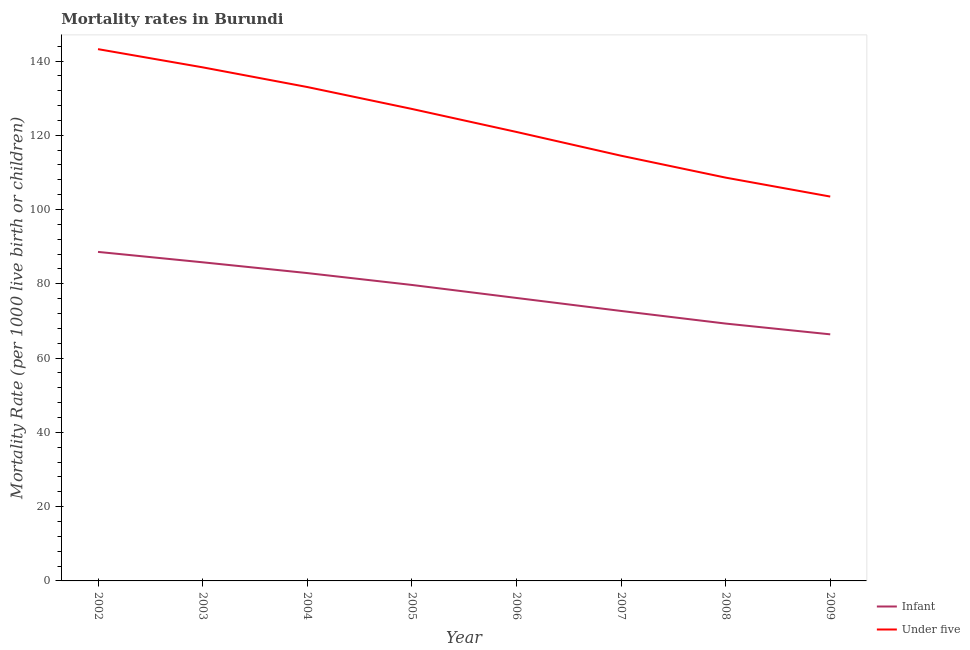What is the under-5 mortality rate in 2009?
Give a very brief answer. 103.5. Across all years, what is the maximum infant mortality rate?
Offer a very short reply. 88.6. Across all years, what is the minimum infant mortality rate?
Your answer should be very brief. 66.4. In which year was the under-5 mortality rate maximum?
Ensure brevity in your answer.  2002. What is the total under-5 mortality rate in the graph?
Your answer should be compact. 989.1. What is the difference between the under-5 mortality rate in 2006 and that in 2008?
Your answer should be very brief. 12.3. What is the difference between the infant mortality rate in 2003 and the under-5 mortality rate in 2007?
Keep it short and to the point. -28.7. What is the average infant mortality rate per year?
Give a very brief answer. 77.7. In the year 2007, what is the difference between the infant mortality rate and under-5 mortality rate?
Make the answer very short. -41.8. What is the ratio of the infant mortality rate in 2006 to that in 2008?
Keep it short and to the point. 1.1. Is the under-5 mortality rate in 2003 less than that in 2006?
Provide a succinct answer. No. What is the difference between the highest and the second highest under-5 mortality rate?
Your response must be concise. 4.9. What is the difference between the highest and the lowest under-5 mortality rate?
Make the answer very short. 39.7. Does the under-5 mortality rate monotonically increase over the years?
Offer a terse response. No. Is the infant mortality rate strictly greater than the under-5 mortality rate over the years?
Ensure brevity in your answer.  No. How many years are there in the graph?
Your answer should be compact. 8. Are the values on the major ticks of Y-axis written in scientific E-notation?
Offer a very short reply. No. How are the legend labels stacked?
Offer a terse response. Vertical. What is the title of the graph?
Your answer should be very brief. Mortality rates in Burundi. Does "Money lenders" appear as one of the legend labels in the graph?
Offer a very short reply. No. What is the label or title of the Y-axis?
Provide a short and direct response. Mortality Rate (per 1000 live birth or children). What is the Mortality Rate (per 1000 live birth or children) of Infant in 2002?
Your answer should be very brief. 88.6. What is the Mortality Rate (per 1000 live birth or children) of Under five in 2002?
Provide a succinct answer. 143.2. What is the Mortality Rate (per 1000 live birth or children) of Infant in 2003?
Your answer should be very brief. 85.8. What is the Mortality Rate (per 1000 live birth or children) in Under five in 2003?
Keep it short and to the point. 138.3. What is the Mortality Rate (per 1000 live birth or children) of Infant in 2004?
Give a very brief answer. 82.9. What is the Mortality Rate (per 1000 live birth or children) of Under five in 2004?
Your response must be concise. 133. What is the Mortality Rate (per 1000 live birth or children) of Infant in 2005?
Your answer should be compact. 79.7. What is the Mortality Rate (per 1000 live birth or children) of Under five in 2005?
Offer a very short reply. 127.1. What is the Mortality Rate (per 1000 live birth or children) of Infant in 2006?
Offer a very short reply. 76.2. What is the Mortality Rate (per 1000 live birth or children) in Under five in 2006?
Ensure brevity in your answer.  120.9. What is the Mortality Rate (per 1000 live birth or children) of Infant in 2007?
Your answer should be compact. 72.7. What is the Mortality Rate (per 1000 live birth or children) in Under five in 2007?
Give a very brief answer. 114.5. What is the Mortality Rate (per 1000 live birth or children) of Infant in 2008?
Provide a succinct answer. 69.3. What is the Mortality Rate (per 1000 live birth or children) of Under five in 2008?
Keep it short and to the point. 108.6. What is the Mortality Rate (per 1000 live birth or children) of Infant in 2009?
Ensure brevity in your answer.  66.4. What is the Mortality Rate (per 1000 live birth or children) of Under five in 2009?
Provide a short and direct response. 103.5. Across all years, what is the maximum Mortality Rate (per 1000 live birth or children) of Infant?
Offer a very short reply. 88.6. Across all years, what is the maximum Mortality Rate (per 1000 live birth or children) in Under five?
Provide a short and direct response. 143.2. Across all years, what is the minimum Mortality Rate (per 1000 live birth or children) in Infant?
Offer a very short reply. 66.4. Across all years, what is the minimum Mortality Rate (per 1000 live birth or children) in Under five?
Your response must be concise. 103.5. What is the total Mortality Rate (per 1000 live birth or children) of Infant in the graph?
Offer a very short reply. 621.6. What is the total Mortality Rate (per 1000 live birth or children) in Under five in the graph?
Make the answer very short. 989.1. What is the difference between the Mortality Rate (per 1000 live birth or children) in Infant in 2002 and that in 2003?
Provide a succinct answer. 2.8. What is the difference between the Mortality Rate (per 1000 live birth or children) in Under five in 2002 and that in 2003?
Offer a terse response. 4.9. What is the difference between the Mortality Rate (per 1000 live birth or children) in Infant in 2002 and that in 2006?
Give a very brief answer. 12.4. What is the difference between the Mortality Rate (per 1000 live birth or children) of Under five in 2002 and that in 2006?
Ensure brevity in your answer.  22.3. What is the difference between the Mortality Rate (per 1000 live birth or children) of Under five in 2002 and that in 2007?
Your response must be concise. 28.7. What is the difference between the Mortality Rate (per 1000 live birth or children) of Infant in 2002 and that in 2008?
Provide a succinct answer. 19.3. What is the difference between the Mortality Rate (per 1000 live birth or children) of Under five in 2002 and that in 2008?
Offer a terse response. 34.6. What is the difference between the Mortality Rate (per 1000 live birth or children) in Under five in 2002 and that in 2009?
Offer a very short reply. 39.7. What is the difference between the Mortality Rate (per 1000 live birth or children) of Under five in 2003 and that in 2005?
Your response must be concise. 11.2. What is the difference between the Mortality Rate (per 1000 live birth or children) in Infant in 2003 and that in 2006?
Give a very brief answer. 9.6. What is the difference between the Mortality Rate (per 1000 live birth or children) of Under five in 2003 and that in 2006?
Your response must be concise. 17.4. What is the difference between the Mortality Rate (per 1000 live birth or children) of Under five in 2003 and that in 2007?
Make the answer very short. 23.8. What is the difference between the Mortality Rate (per 1000 live birth or children) of Under five in 2003 and that in 2008?
Ensure brevity in your answer.  29.7. What is the difference between the Mortality Rate (per 1000 live birth or children) in Under five in 2003 and that in 2009?
Give a very brief answer. 34.8. What is the difference between the Mortality Rate (per 1000 live birth or children) of Infant in 2004 and that in 2005?
Keep it short and to the point. 3.2. What is the difference between the Mortality Rate (per 1000 live birth or children) of Under five in 2004 and that in 2006?
Keep it short and to the point. 12.1. What is the difference between the Mortality Rate (per 1000 live birth or children) of Under five in 2004 and that in 2007?
Offer a very short reply. 18.5. What is the difference between the Mortality Rate (per 1000 live birth or children) in Infant in 2004 and that in 2008?
Your answer should be very brief. 13.6. What is the difference between the Mortality Rate (per 1000 live birth or children) of Under five in 2004 and that in 2008?
Provide a succinct answer. 24.4. What is the difference between the Mortality Rate (per 1000 live birth or children) in Infant in 2004 and that in 2009?
Your answer should be very brief. 16.5. What is the difference between the Mortality Rate (per 1000 live birth or children) in Under five in 2004 and that in 2009?
Keep it short and to the point. 29.5. What is the difference between the Mortality Rate (per 1000 live birth or children) of Infant in 2005 and that in 2006?
Offer a terse response. 3.5. What is the difference between the Mortality Rate (per 1000 live birth or children) of Under five in 2005 and that in 2007?
Give a very brief answer. 12.6. What is the difference between the Mortality Rate (per 1000 live birth or children) of Infant in 2005 and that in 2008?
Offer a very short reply. 10.4. What is the difference between the Mortality Rate (per 1000 live birth or children) in Under five in 2005 and that in 2008?
Your response must be concise. 18.5. What is the difference between the Mortality Rate (per 1000 live birth or children) in Infant in 2005 and that in 2009?
Provide a short and direct response. 13.3. What is the difference between the Mortality Rate (per 1000 live birth or children) of Under five in 2005 and that in 2009?
Your answer should be compact. 23.6. What is the difference between the Mortality Rate (per 1000 live birth or children) in Infant in 2006 and that in 2008?
Offer a terse response. 6.9. What is the difference between the Mortality Rate (per 1000 live birth or children) of Under five in 2006 and that in 2008?
Your answer should be compact. 12.3. What is the difference between the Mortality Rate (per 1000 live birth or children) of Infant in 2006 and that in 2009?
Your answer should be very brief. 9.8. What is the difference between the Mortality Rate (per 1000 live birth or children) in Infant in 2007 and that in 2008?
Give a very brief answer. 3.4. What is the difference between the Mortality Rate (per 1000 live birth or children) in Under five in 2007 and that in 2008?
Provide a succinct answer. 5.9. What is the difference between the Mortality Rate (per 1000 live birth or children) in Infant in 2007 and that in 2009?
Offer a terse response. 6.3. What is the difference between the Mortality Rate (per 1000 live birth or children) in Infant in 2008 and that in 2009?
Your answer should be compact. 2.9. What is the difference between the Mortality Rate (per 1000 live birth or children) of Infant in 2002 and the Mortality Rate (per 1000 live birth or children) of Under five in 2003?
Your answer should be very brief. -49.7. What is the difference between the Mortality Rate (per 1000 live birth or children) in Infant in 2002 and the Mortality Rate (per 1000 live birth or children) in Under five in 2004?
Your answer should be compact. -44.4. What is the difference between the Mortality Rate (per 1000 live birth or children) of Infant in 2002 and the Mortality Rate (per 1000 live birth or children) of Under five in 2005?
Your answer should be very brief. -38.5. What is the difference between the Mortality Rate (per 1000 live birth or children) of Infant in 2002 and the Mortality Rate (per 1000 live birth or children) of Under five in 2006?
Give a very brief answer. -32.3. What is the difference between the Mortality Rate (per 1000 live birth or children) in Infant in 2002 and the Mortality Rate (per 1000 live birth or children) in Under five in 2007?
Your answer should be very brief. -25.9. What is the difference between the Mortality Rate (per 1000 live birth or children) in Infant in 2002 and the Mortality Rate (per 1000 live birth or children) in Under five in 2009?
Offer a terse response. -14.9. What is the difference between the Mortality Rate (per 1000 live birth or children) of Infant in 2003 and the Mortality Rate (per 1000 live birth or children) of Under five in 2004?
Give a very brief answer. -47.2. What is the difference between the Mortality Rate (per 1000 live birth or children) of Infant in 2003 and the Mortality Rate (per 1000 live birth or children) of Under five in 2005?
Make the answer very short. -41.3. What is the difference between the Mortality Rate (per 1000 live birth or children) in Infant in 2003 and the Mortality Rate (per 1000 live birth or children) in Under five in 2006?
Make the answer very short. -35.1. What is the difference between the Mortality Rate (per 1000 live birth or children) of Infant in 2003 and the Mortality Rate (per 1000 live birth or children) of Under five in 2007?
Keep it short and to the point. -28.7. What is the difference between the Mortality Rate (per 1000 live birth or children) in Infant in 2003 and the Mortality Rate (per 1000 live birth or children) in Under five in 2008?
Your answer should be very brief. -22.8. What is the difference between the Mortality Rate (per 1000 live birth or children) in Infant in 2003 and the Mortality Rate (per 1000 live birth or children) in Under five in 2009?
Your answer should be very brief. -17.7. What is the difference between the Mortality Rate (per 1000 live birth or children) in Infant in 2004 and the Mortality Rate (per 1000 live birth or children) in Under five in 2005?
Provide a succinct answer. -44.2. What is the difference between the Mortality Rate (per 1000 live birth or children) of Infant in 2004 and the Mortality Rate (per 1000 live birth or children) of Under five in 2006?
Offer a very short reply. -38. What is the difference between the Mortality Rate (per 1000 live birth or children) of Infant in 2004 and the Mortality Rate (per 1000 live birth or children) of Under five in 2007?
Provide a short and direct response. -31.6. What is the difference between the Mortality Rate (per 1000 live birth or children) in Infant in 2004 and the Mortality Rate (per 1000 live birth or children) in Under five in 2008?
Make the answer very short. -25.7. What is the difference between the Mortality Rate (per 1000 live birth or children) in Infant in 2004 and the Mortality Rate (per 1000 live birth or children) in Under five in 2009?
Provide a short and direct response. -20.6. What is the difference between the Mortality Rate (per 1000 live birth or children) of Infant in 2005 and the Mortality Rate (per 1000 live birth or children) of Under five in 2006?
Offer a very short reply. -41.2. What is the difference between the Mortality Rate (per 1000 live birth or children) of Infant in 2005 and the Mortality Rate (per 1000 live birth or children) of Under five in 2007?
Your answer should be very brief. -34.8. What is the difference between the Mortality Rate (per 1000 live birth or children) of Infant in 2005 and the Mortality Rate (per 1000 live birth or children) of Under five in 2008?
Provide a succinct answer. -28.9. What is the difference between the Mortality Rate (per 1000 live birth or children) in Infant in 2005 and the Mortality Rate (per 1000 live birth or children) in Under five in 2009?
Offer a very short reply. -23.8. What is the difference between the Mortality Rate (per 1000 live birth or children) in Infant in 2006 and the Mortality Rate (per 1000 live birth or children) in Under five in 2007?
Your answer should be compact. -38.3. What is the difference between the Mortality Rate (per 1000 live birth or children) of Infant in 2006 and the Mortality Rate (per 1000 live birth or children) of Under five in 2008?
Offer a terse response. -32.4. What is the difference between the Mortality Rate (per 1000 live birth or children) of Infant in 2006 and the Mortality Rate (per 1000 live birth or children) of Under five in 2009?
Offer a terse response. -27.3. What is the difference between the Mortality Rate (per 1000 live birth or children) of Infant in 2007 and the Mortality Rate (per 1000 live birth or children) of Under five in 2008?
Your answer should be very brief. -35.9. What is the difference between the Mortality Rate (per 1000 live birth or children) in Infant in 2007 and the Mortality Rate (per 1000 live birth or children) in Under five in 2009?
Your answer should be compact. -30.8. What is the difference between the Mortality Rate (per 1000 live birth or children) in Infant in 2008 and the Mortality Rate (per 1000 live birth or children) in Under five in 2009?
Offer a very short reply. -34.2. What is the average Mortality Rate (per 1000 live birth or children) in Infant per year?
Your response must be concise. 77.7. What is the average Mortality Rate (per 1000 live birth or children) of Under five per year?
Offer a terse response. 123.64. In the year 2002, what is the difference between the Mortality Rate (per 1000 live birth or children) of Infant and Mortality Rate (per 1000 live birth or children) of Under five?
Your answer should be compact. -54.6. In the year 2003, what is the difference between the Mortality Rate (per 1000 live birth or children) in Infant and Mortality Rate (per 1000 live birth or children) in Under five?
Ensure brevity in your answer.  -52.5. In the year 2004, what is the difference between the Mortality Rate (per 1000 live birth or children) of Infant and Mortality Rate (per 1000 live birth or children) of Under five?
Provide a succinct answer. -50.1. In the year 2005, what is the difference between the Mortality Rate (per 1000 live birth or children) in Infant and Mortality Rate (per 1000 live birth or children) in Under five?
Make the answer very short. -47.4. In the year 2006, what is the difference between the Mortality Rate (per 1000 live birth or children) of Infant and Mortality Rate (per 1000 live birth or children) of Under five?
Your answer should be very brief. -44.7. In the year 2007, what is the difference between the Mortality Rate (per 1000 live birth or children) in Infant and Mortality Rate (per 1000 live birth or children) in Under five?
Offer a terse response. -41.8. In the year 2008, what is the difference between the Mortality Rate (per 1000 live birth or children) of Infant and Mortality Rate (per 1000 live birth or children) of Under five?
Your response must be concise. -39.3. In the year 2009, what is the difference between the Mortality Rate (per 1000 live birth or children) of Infant and Mortality Rate (per 1000 live birth or children) of Under five?
Make the answer very short. -37.1. What is the ratio of the Mortality Rate (per 1000 live birth or children) in Infant in 2002 to that in 2003?
Your response must be concise. 1.03. What is the ratio of the Mortality Rate (per 1000 live birth or children) of Under five in 2002 to that in 2003?
Offer a very short reply. 1.04. What is the ratio of the Mortality Rate (per 1000 live birth or children) in Infant in 2002 to that in 2004?
Ensure brevity in your answer.  1.07. What is the ratio of the Mortality Rate (per 1000 live birth or children) in Under five in 2002 to that in 2004?
Your answer should be compact. 1.08. What is the ratio of the Mortality Rate (per 1000 live birth or children) in Infant in 2002 to that in 2005?
Keep it short and to the point. 1.11. What is the ratio of the Mortality Rate (per 1000 live birth or children) of Under five in 2002 to that in 2005?
Provide a short and direct response. 1.13. What is the ratio of the Mortality Rate (per 1000 live birth or children) in Infant in 2002 to that in 2006?
Your answer should be very brief. 1.16. What is the ratio of the Mortality Rate (per 1000 live birth or children) in Under five in 2002 to that in 2006?
Offer a terse response. 1.18. What is the ratio of the Mortality Rate (per 1000 live birth or children) of Infant in 2002 to that in 2007?
Keep it short and to the point. 1.22. What is the ratio of the Mortality Rate (per 1000 live birth or children) in Under five in 2002 to that in 2007?
Your response must be concise. 1.25. What is the ratio of the Mortality Rate (per 1000 live birth or children) in Infant in 2002 to that in 2008?
Offer a terse response. 1.28. What is the ratio of the Mortality Rate (per 1000 live birth or children) of Under five in 2002 to that in 2008?
Your response must be concise. 1.32. What is the ratio of the Mortality Rate (per 1000 live birth or children) in Infant in 2002 to that in 2009?
Offer a very short reply. 1.33. What is the ratio of the Mortality Rate (per 1000 live birth or children) of Under five in 2002 to that in 2009?
Offer a terse response. 1.38. What is the ratio of the Mortality Rate (per 1000 live birth or children) of Infant in 2003 to that in 2004?
Provide a succinct answer. 1.03. What is the ratio of the Mortality Rate (per 1000 live birth or children) in Under five in 2003 to that in 2004?
Give a very brief answer. 1.04. What is the ratio of the Mortality Rate (per 1000 live birth or children) in Infant in 2003 to that in 2005?
Keep it short and to the point. 1.08. What is the ratio of the Mortality Rate (per 1000 live birth or children) in Under five in 2003 to that in 2005?
Offer a terse response. 1.09. What is the ratio of the Mortality Rate (per 1000 live birth or children) in Infant in 2003 to that in 2006?
Ensure brevity in your answer.  1.13. What is the ratio of the Mortality Rate (per 1000 live birth or children) of Under five in 2003 to that in 2006?
Give a very brief answer. 1.14. What is the ratio of the Mortality Rate (per 1000 live birth or children) in Infant in 2003 to that in 2007?
Make the answer very short. 1.18. What is the ratio of the Mortality Rate (per 1000 live birth or children) in Under five in 2003 to that in 2007?
Offer a terse response. 1.21. What is the ratio of the Mortality Rate (per 1000 live birth or children) of Infant in 2003 to that in 2008?
Your answer should be compact. 1.24. What is the ratio of the Mortality Rate (per 1000 live birth or children) of Under five in 2003 to that in 2008?
Offer a terse response. 1.27. What is the ratio of the Mortality Rate (per 1000 live birth or children) in Infant in 2003 to that in 2009?
Provide a short and direct response. 1.29. What is the ratio of the Mortality Rate (per 1000 live birth or children) of Under five in 2003 to that in 2009?
Offer a very short reply. 1.34. What is the ratio of the Mortality Rate (per 1000 live birth or children) in Infant in 2004 to that in 2005?
Provide a short and direct response. 1.04. What is the ratio of the Mortality Rate (per 1000 live birth or children) in Under five in 2004 to that in 2005?
Ensure brevity in your answer.  1.05. What is the ratio of the Mortality Rate (per 1000 live birth or children) of Infant in 2004 to that in 2006?
Offer a terse response. 1.09. What is the ratio of the Mortality Rate (per 1000 live birth or children) of Under five in 2004 to that in 2006?
Provide a short and direct response. 1.1. What is the ratio of the Mortality Rate (per 1000 live birth or children) of Infant in 2004 to that in 2007?
Your answer should be compact. 1.14. What is the ratio of the Mortality Rate (per 1000 live birth or children) in Under five in 2004 to that in 2007?
Provide a short and direct response. 1.16. What is the ratio of the Mortality Rate (per 1000 live birth or children) of Infant in 2004 to that in 2008?
Offer a terse response. 1.2. What is the ratio of the Mortality Rate (per 1000 live birth or children) in Under five in 2004 to that in 2008?
Ensure brevity in your answer.  1.22. What is the ratio of the Mortality Rate (per 1000 live birth or children) in Infant in 2004 to that in 2009?
Keep it short and to the point. 1.25. What is the ratio of the Mortality Rate (per 1000 live birth or children) in Under five in 2004 to that in 2009?
Offer a terse response. 1.28. What is the ratio of the Mortality Rate (per 1000 live birth or children) of Infant in 2005 to that in 2006?
Your response must be concise. 1.05. What is the ratio of the Mortality Rate (per 1000 live birth or children) of Under five in 2005 to that in 2006?
Provide a succinct answer. 1.05. What is the ratio of the Mortality Rate (per 1000 live birth or children) of Infant in 2005 to that in 2007?
Provide a succinct answer. 1.1. What is the ratio of the Mortality Rate (per 1000 live birth or children) in Under five in 2005 to that in 2007?
Provide a short and direct response. 1.11. What is the ratio of the Mortality Rate (per 1000 live birth or children) of Infant in 2005 to that in 2008?
Provide a short and direct response. 1.15. What is the ratio of the Mortality Rate (per 1000 live birth or children) of Under five in 2005 to that in 2008?
Offer a very short reply. 1.17. What is the ratio of the Mortality Rate (per 1000 live birth or children) of Infant in 2005 to that in 2009?
Ensure brevity in your answer.  1.2. What is the ratio of the Mortality Rate (per 1000 live birth or children) of Under five in 2005 to that in 2009?
Ensure brevity in your answer.  1.23. What is the ratio of the Mortality Rate (per 1000 live birth or children) of Infant in 2006 to that in 2007?
Your answer should be very brief. 1.05. What is the ratio of the Mortality Rate (per 1000 live birth or children) of Under five in 2006 to that in 2007?
Provide a succinct answer. 1.06. What is the ratio of the Mortality Rate (per 1000 live birth or children) of Infant in 2006 to that in 2008?
Your answer should be very brief. 1.1. What is the ratio of the Mortality Rate (per 1000 live birth or children) in Under five in 2006 to that in 2008?
Give a very brief answer. 1.11. What is the ratio of the Mortality Rate (per 1000 live birth or children) in Infant in 2006 to that in 2009?
Provide a short and direct response. 1.15. What is the ratio of the Mortality Rate (per 1000 live birth or children) in Under five in 2006 to that in 2009?
Provide a succinct answer. 1.17. What is the ratio of the Mortality Rate (per 1000 live birth or children) in Infant in 2007 to that in 2008?
Offer a terse response. 1.05. What is the ratio of the Mortality Rate (per 1000 live birth or children) in Under five in 2007 to that in 2008?
Give a very brief answer. 1.05. What is the ratio of the Mortality Rate (per 1000 live birth or children) of Infant in 2007 to that in 2009?
Offer a very short reply. 1.09. What is the ratio of the Mortality Rate (per 1000 live birth or children) of Under five in 2007 to that in 2009?
Make the answer very short. 1.11. What is the ratio of the Mortality Rate (per 1000 live birth or children) of Infant in 2008 to that in 2009?
Make the answer very short. 1.04. What is the ratio of the Mortality Rate (per 1000 live birth or children) of Under five in 2008 to that in 2009?
Make the answer very short. 1.05. What is the difference between the highest and the lowest Mortality Rate (per 1000 live birth or children) in Infant?
Provide a short and direct response. 22.2. What is the difference between the highest and the lowest Mortality Rate (per 1000 live birth or children) of Under five?
Your answer should be compact. 39.7. 